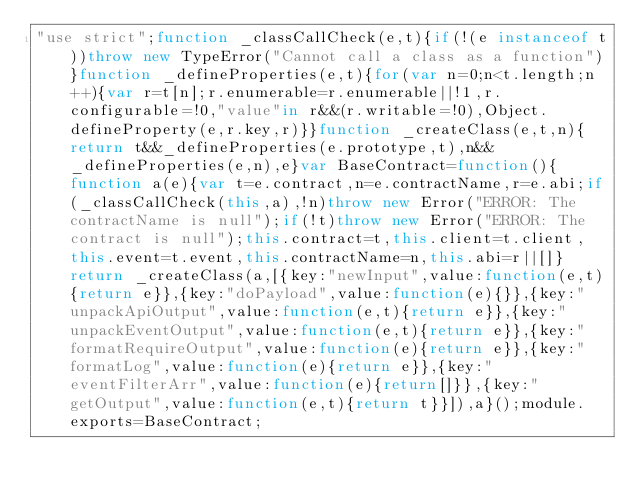<code> <loc_0><loc_0><loc_500><loc_500><_JavaScript_>"use strict";function _classCallCheck(e,t){if(!(e instanceof t))throw new TypeError("Cannot call a class as a function")}function _defineProperties(e,t){for(var n=0;n<t.length;n++){var r=t[n];r.enumerable=r.enumerable||!1,r.configurable=!0,"value"in r&&(r.writable=!0),Object.defineProperty(e,r.key,r)}}function _createClass(e,t,n){return t&&_defineProperties(e.prototype,t),n&&_defineProperties(e,n),e}var BaseContract=function(){function a(e){var t=e.contract,n=e.contractName,r=e.abi;if(_classCallCheck(this,a),!n)throw new Error("ERROR: The contractName is null");if(!t)throw new Error("ERROR: The contract is null");this.contract=t,this.client=t.client,this.event=t.event,this.contractName=n,this.abi=r||[]}return _createClass(a,[{key:"newInput",value:function(e,t){return e}},{key:"doPayload",value:function(e){}},{key:"unpackApiOutput",value:function(e,t){return e}},{key:"unpackEventOutput",value:function(e,t){return e}},{key:"formatRequireOutput",value:function(e){return e}},{key:"formatLog",value:function(e){return e}},{key:"eventFilterArr",value:function(e){return[]}},{key:"getOutput",value:function(e,t){return t}}]),a}();module.exports=BaseContract;</code> 